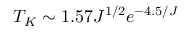Convert formula to latex. <formula><loc_0><loc_0><loc_500><loc_500>T _ { K } \sim 1 . 5 7 J ^ { 1 / 2 } e ^ { - 4 . 5 / J }</formula> 